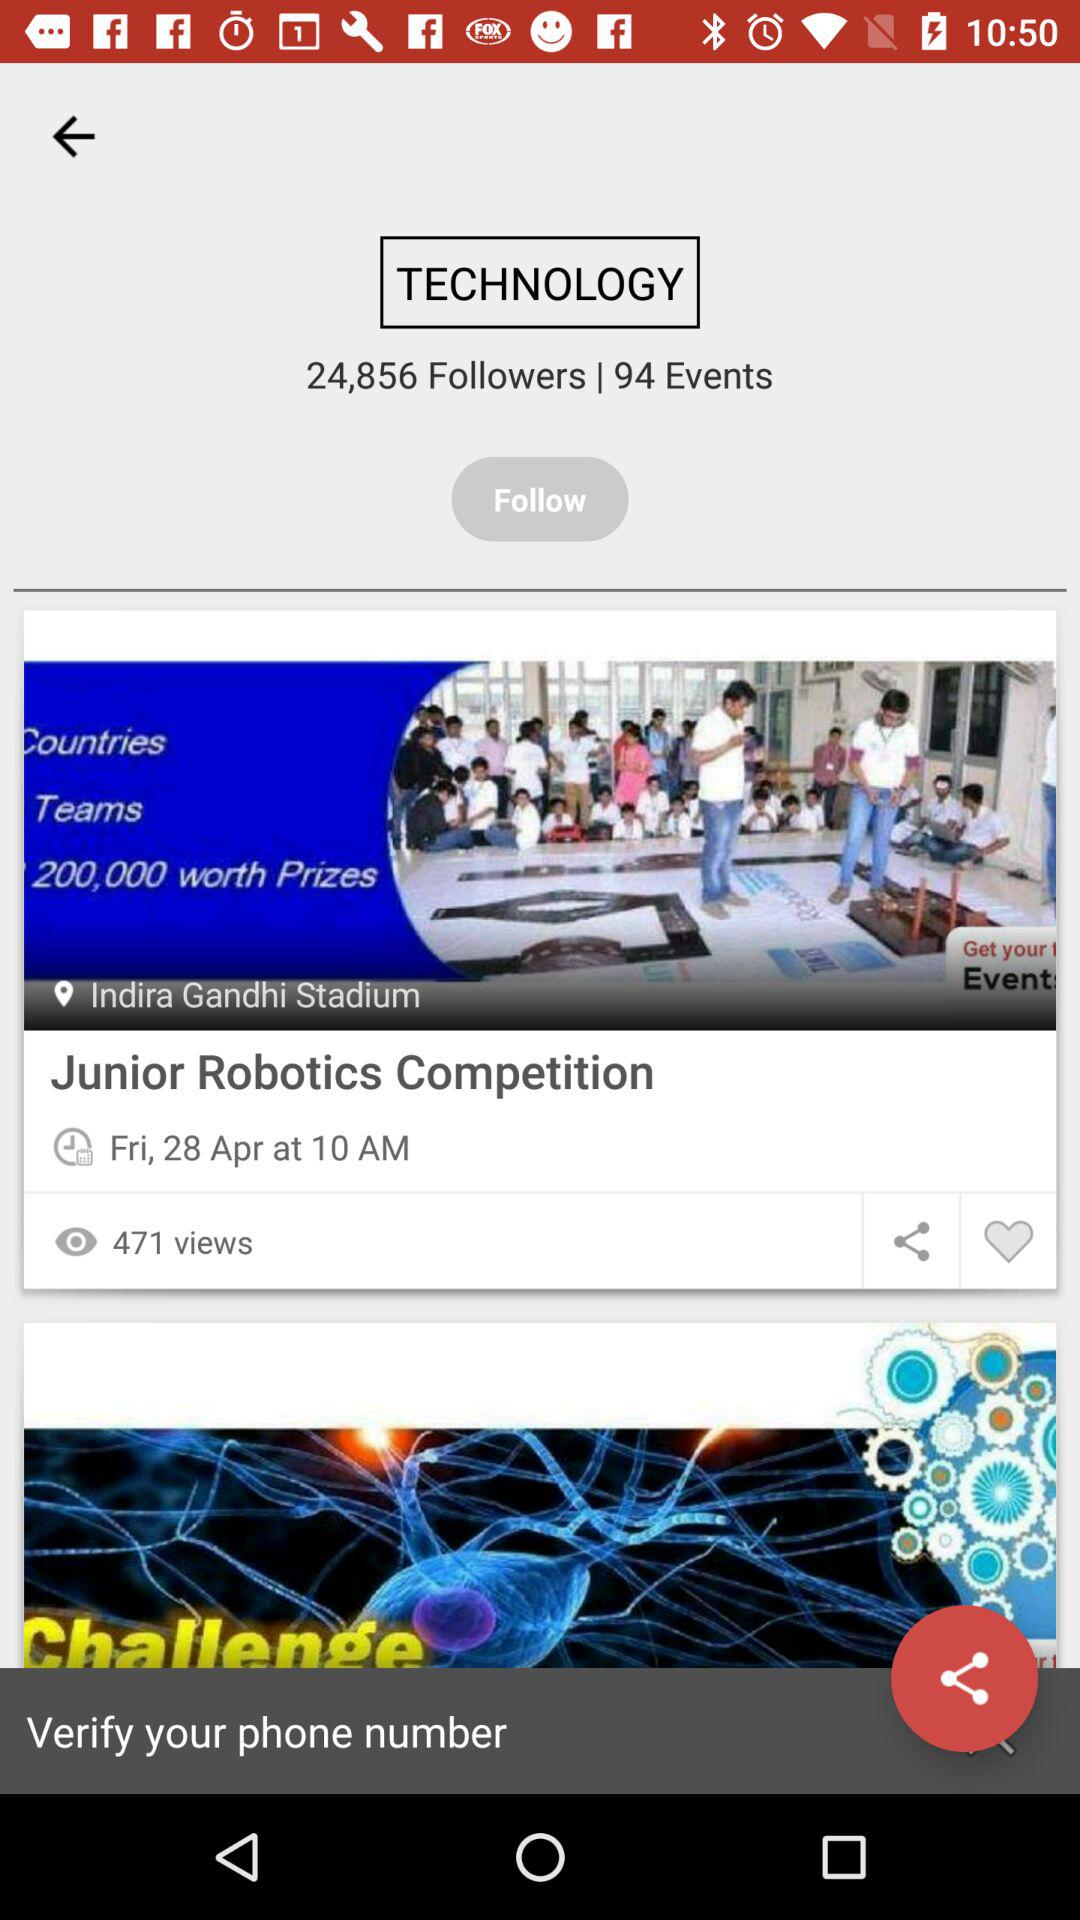How many followers are there? There are 24,856 followers. 